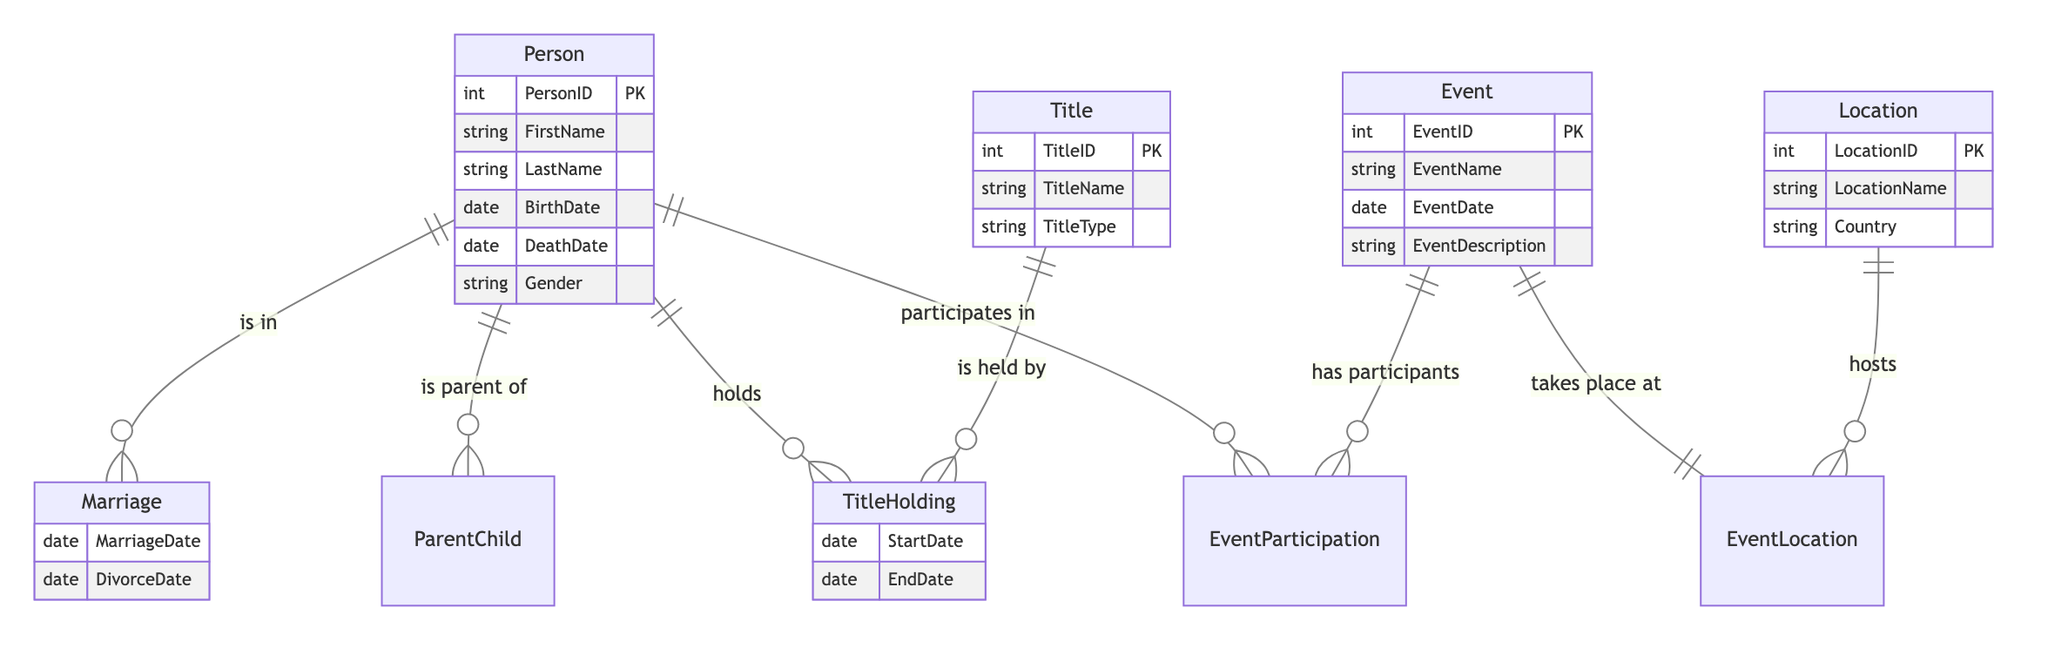What is the primary relationship type connecting two persons in the diagram? The diagram shows that the primary relationship type connecting two persons is "Marriage," which indicates a significant connection between individuals.
Answer: Marriage How many entities are in the diagram? There are four entities in the diagram: Person, Title, Event, and Location. This is determined by counting the unique entity types listed.
Answer: 4 Which entity holds multiple titles? The "TitleHolding" relationship indicates that a "Person" can hold multiple "Title" entities. This is derived from the linking nature of the relationships in the diagram.
Answer: Person What attribute describes the duration of a title held by a person? The attributes associated with the "TitleHolding" relationship include "StartDate" and "EndDate," indicating the period during which a title is held.
Answer: StartDate, EndDate How are events related to locations in the diagram? The diagram indicates a direct relationship called "EventLocation," which connects the entities "Event" and "Location," showing where events take place.
Answer: EventLocation What does the participation of a person in an event signify? The "EventParticipation" relationship shows that individuals participate in events, indicating involvement or presence at specific occasions.
Answer: EventParticipation Which relationship defines the connection between parents and children in the diagram? The "ParentChild" relationship specifically defines the connection where one person is a parent of another, showing familial links.
Answer: ParentChild Which attribute specifies the date of a marriage event? The attribute "MarriageDate" within the "Marriage" relationship provides the specific date when a marriage occurred.
Answer: MarriageDate How many types of titles are represented in the diagram? The "Title" entity has an attribute "TitleType," which can accommodate multiple types; however, the exact number depends on the instances of titles not shown in the diagram.
Answer: Multiple types What is the significance of the "EventDescription" attribute? The "EventDescription" attribute under the "Event" entity provides important contextual information about each event, detailing what occurred.
Answer: EventDescription 